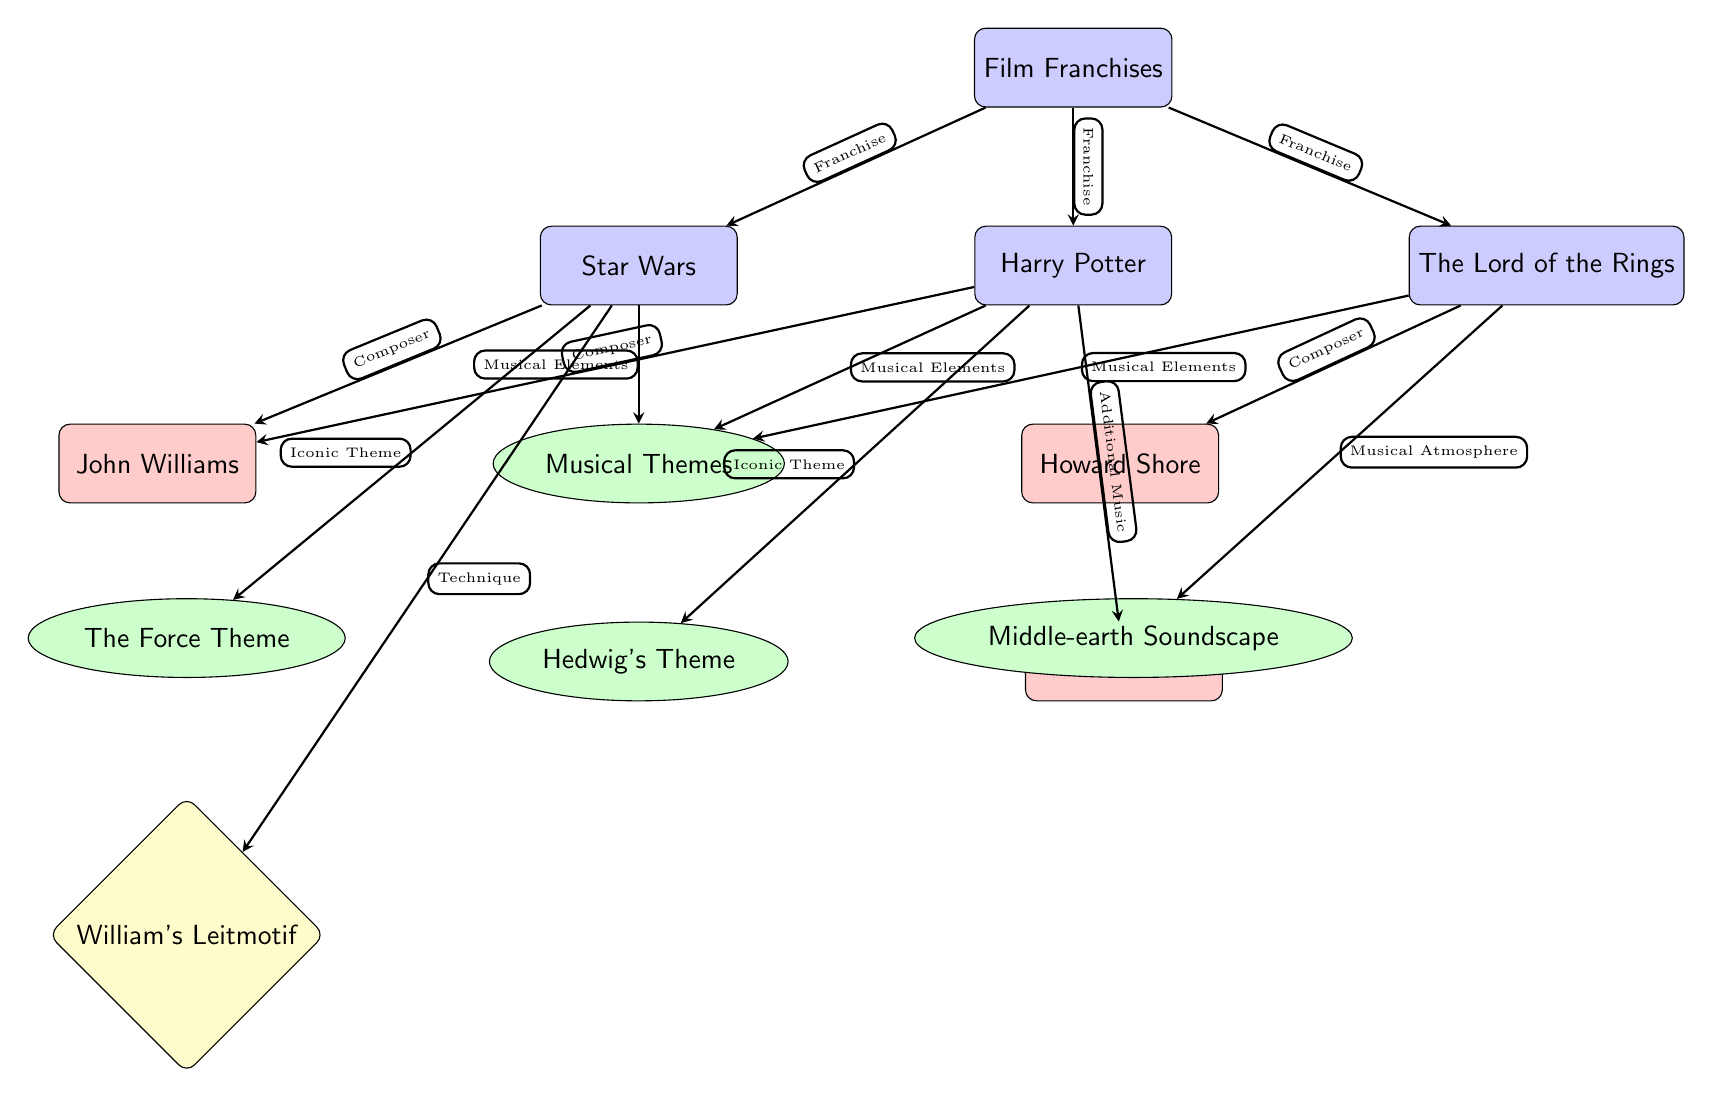What are the three film franchises depicted in the diagram? The diagram's main node lists three franchises: Star Wars, Harry Potter, and The Lord of the Rings. These are all visually represented below the "Film Franchises" node.
Answer: Star Wars, Harry Potter, The Lord of the Rings Who composed the music for Star Wars? In the diagram, the composer connected to Star Wars is identified with an edge leading from Star Wars to the node labeled John Williams.
Answer: John Williams What musical theme is associated with Harry Potter? The diagram shows a direct association between the Harry Potter franchise and the theme labeled Hedwig's Theme, which is directly connected below the franchise.
Answer: Hedwig's Theme How many composers are featured in the diagram? The diagram contains two composer nodes: John Williams and Howard Shore, indicating that there are two composers featured.
Answer: 2 Which technique is specifically linked to the Force Theme? The diagram indicates a connection from the Force Theme to the technique labeled William's Leitmotif. This is explicitly shown in the diagram as a direct relationship.
Answer: William's Leitmotif Which film franchise has a musical atmosphere? The diagram shows that the node labeled Middle-earth Soundscape is connected to The Lord of the Rings franchise, indicating that this franchise has a musical atmosphere.
Answer: The Lord of the Rings What connects Harry Potter to its additional music composer? The diagram illustrates that Harry Potter is associated with the composer Jeremy Soule through an edge labeled Additional Music, showing the relationship clearly.
Answer: Jeremy Soule Which franchise is associated with Howard Shore? The diagram indicates that Howard Shore is connected to The Lord of the Rings franchise, which can be confirmed through the directed edge between them.
Answer: The Lord of the Rings How many musical themes are represented in the diagram? The diagram lists three specific musical themes: The Force Theme, Hedwig's Theme, and Middle-earth Soundscape, therefore counting reveals there are three themes.
Answer: 3 